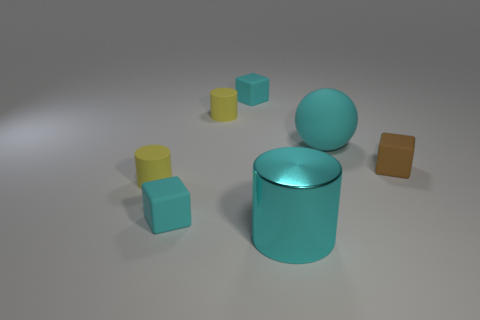There is a tiny cyan rubber object in front of the tiny brown cube; does it have the same shape as the large cyan matte thing?
Give a very brief answer. No. Are there more big cyan spheres that are on the left side of the large cyan metal cylinder than cyan rubber cubes that are on the left side of the cyan ball?
Give a very brief answer. No. What number of yellow things are the same material as the sphere?
Your response must be concise. 2. Does the metallic thing have the same size as the brown object?
Your answer should be very brief. No. What color is the ball?
Provide a short and direct response. Cyan. What number of objects are large purple rubber spheres or tiny brown matte objects?
Provide a succinct answer. 1. Are there any big cyan things that have the same shape as the tiny brown rubber object?
Your response must be concise. No. Does the small cube that is behind the large rubber object have the same color as the big shiny cylinder?
Ensure brevity in your answer.  Yes. What is the shape of the small cyan thing that is to the left of the tiny yellow rubber thing behind the ball?
Offer a very short reply. Cube. Are there any cyan things that have the same size as the cyan sphere?
Your response must be concise. Yes. 